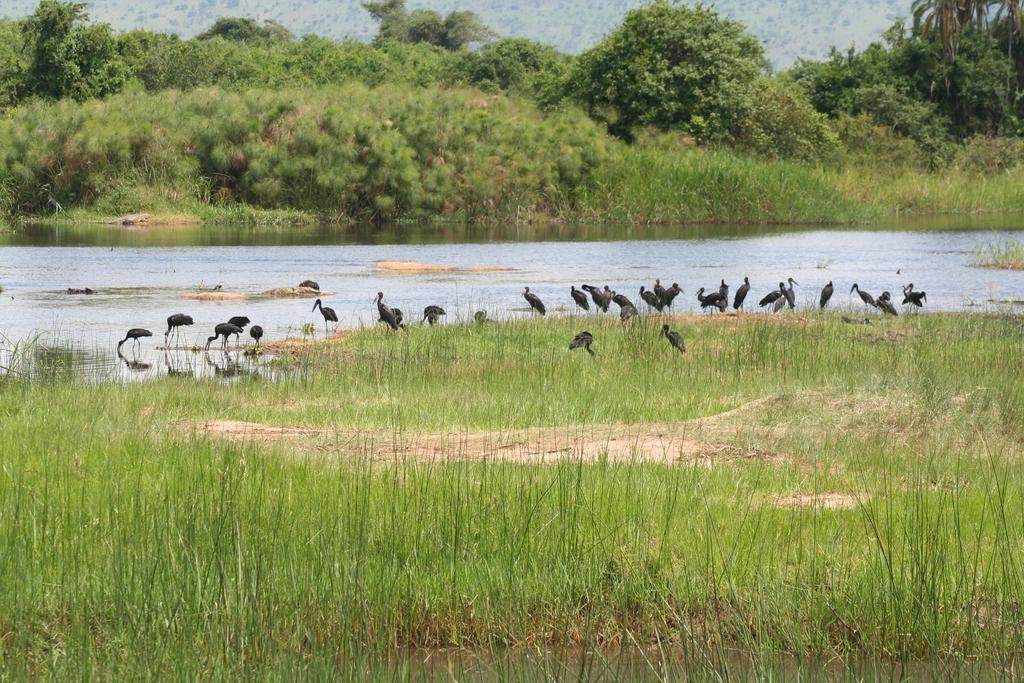Can you describe this image briefly? This picture is clicked outside the city. In the foreground we can see the green grass and the group of birds standing on the ground. In the center there is a water body. In the background we can see the sky, trees, plants and the grass. 